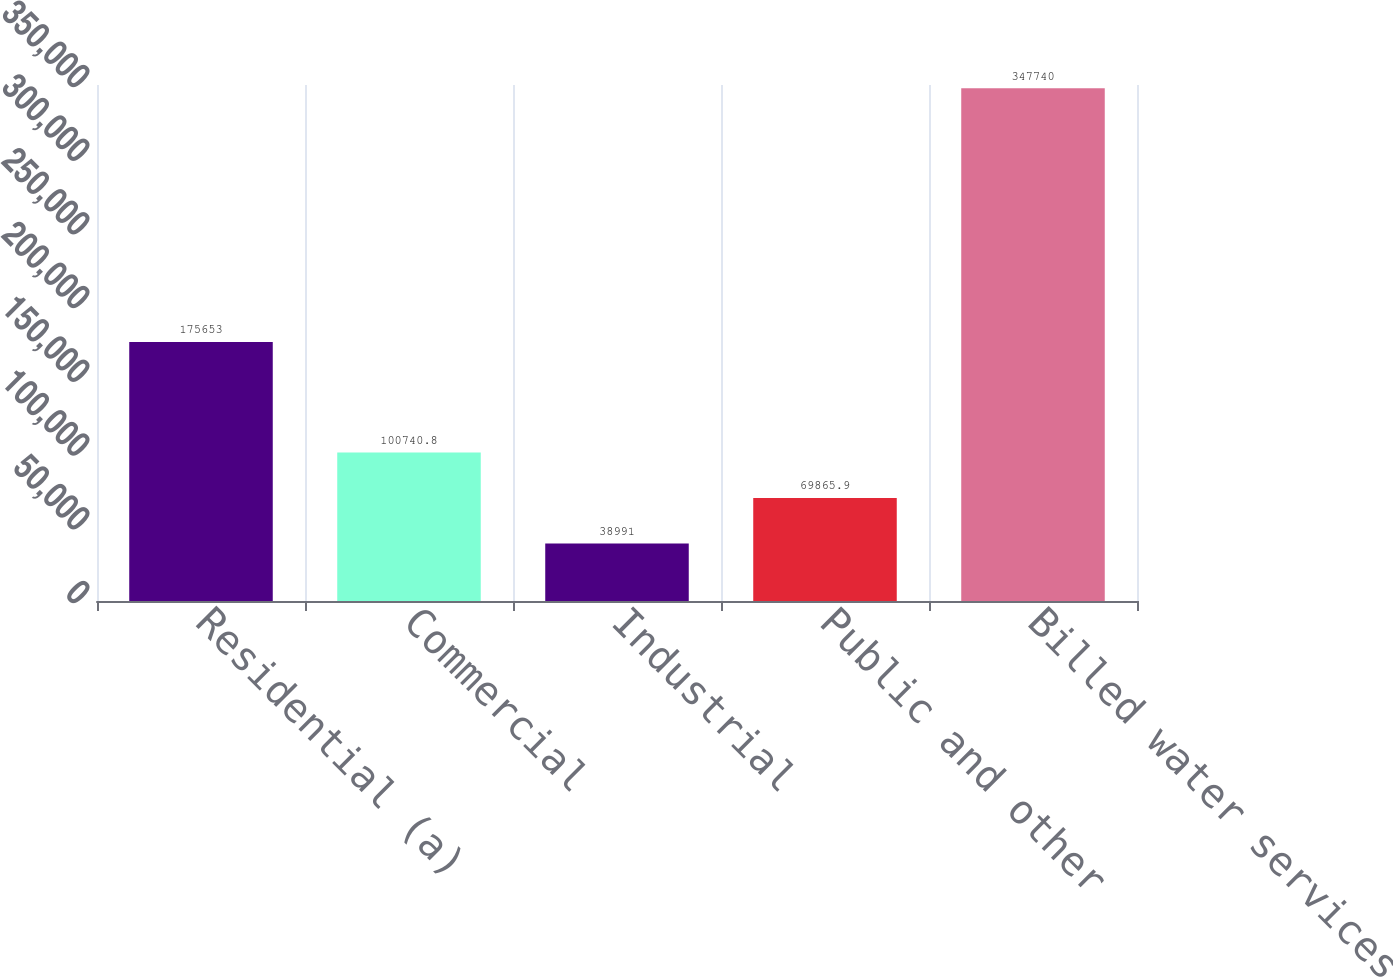<chart> <loc_0><loc_0><loc_500><loc_500><bar_chart><fcel>Residential (a)<fcel>Commercial<fcel>Industrial<fcel>Public and other<fcel>Billed water services<nl><fcel>175653<fcel>100741<fcel>38991<fcel>69865.9<fcel>347740<nl></chart> 